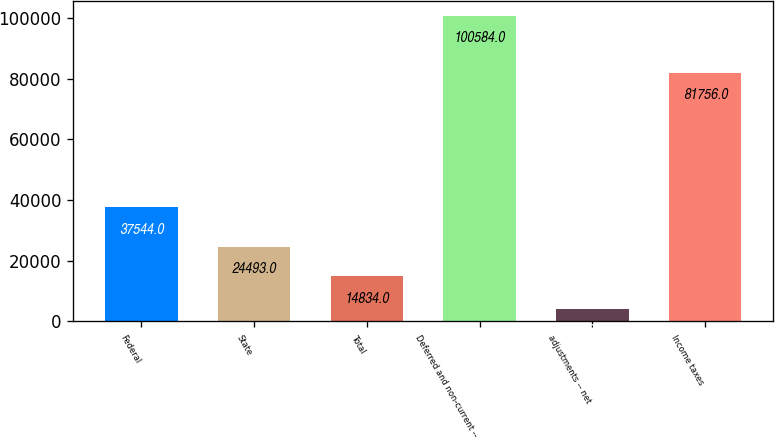<chart> <loc_0><loc_0><loc_500><loc_500><bar_chart><fcel>Federal<fcel>State<fcel>Total<fcel>Deferred and non-current --<fcel>adjustments -- net<fcel>Income taxes<nl><fcel>37544<fcel>24493<fcel>14834<fcel>100584<fcel>3994<fcel>81756<nl></chart> 